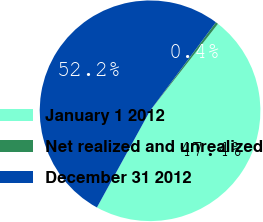Convert chart to OTSL. <chart><loc_0><loc_0><loc_500><loc_500><pie_chart><fcel>January 1 2012<fcel>Net realized and unrealized<fcel>December 31 2012<nl><fcel>47.44%<fcel>0.38%<fcel>52.18%<nl></chart> 